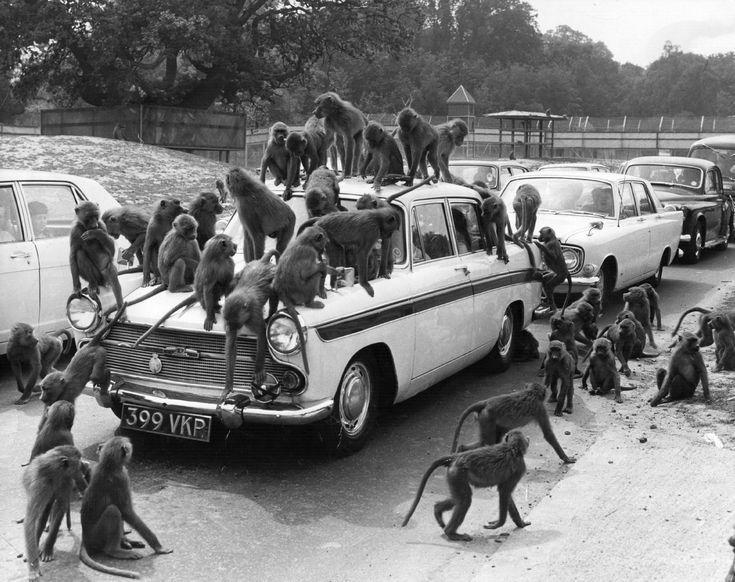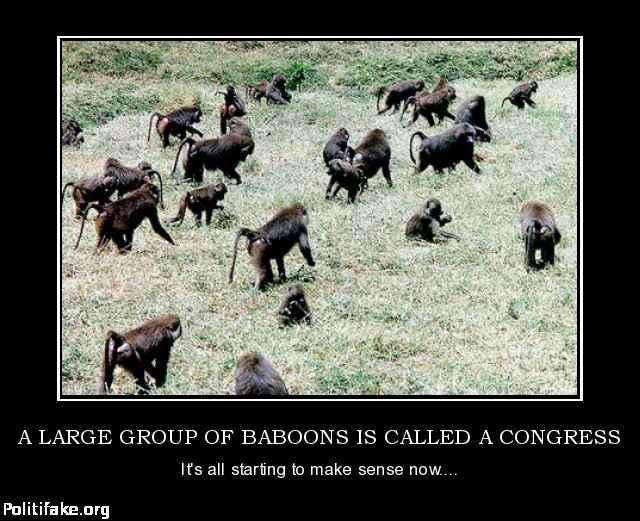The first image is the image on the left, the second image is the image on the right. Considering the images on both sides, is "there are man made objects in the image on the left." valid? Answer yes or no. Yes. 